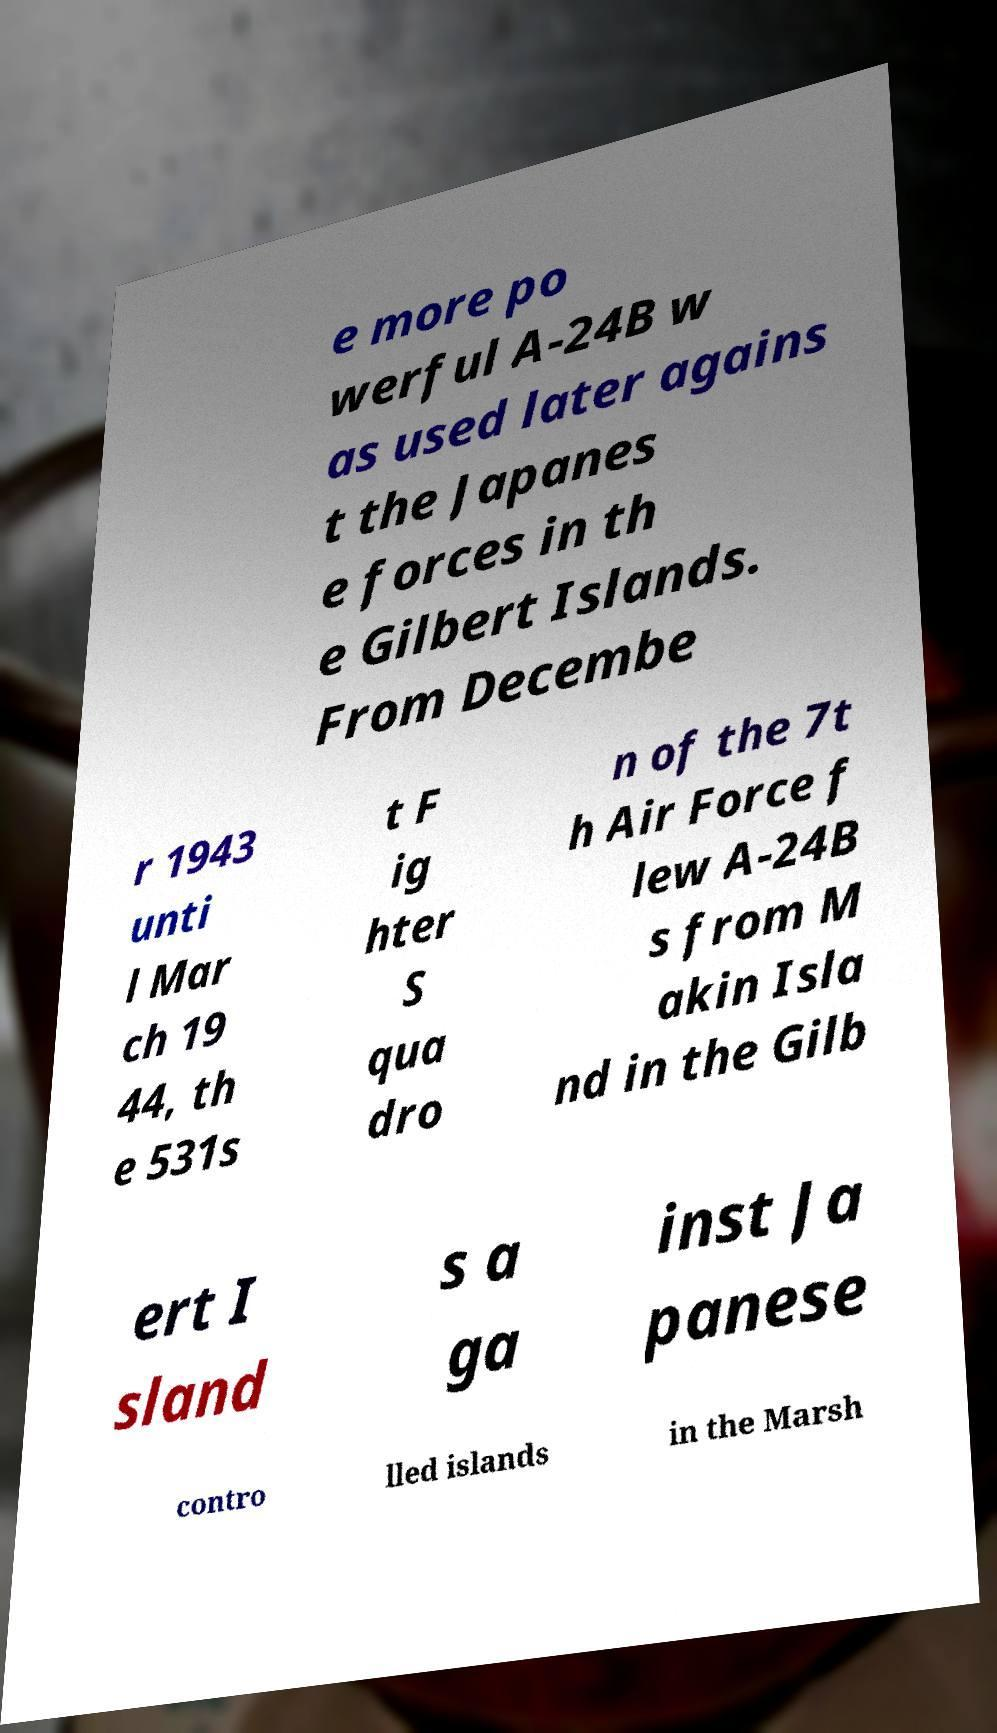Could you extract and type out the text from this image? e more po werful A-24B w as used later agains t the Japanes e forces in th e Gilbert Islands. From Decembe r 1943 unti l Mar ch 19 44, th e 531s t F ig hter S qua dro n of the 7t h Air Force f lew A-24B s from M akin Isla nd in the Gilb ert I sland s a ga inst Ja panese contro lled islands in the Marsh 